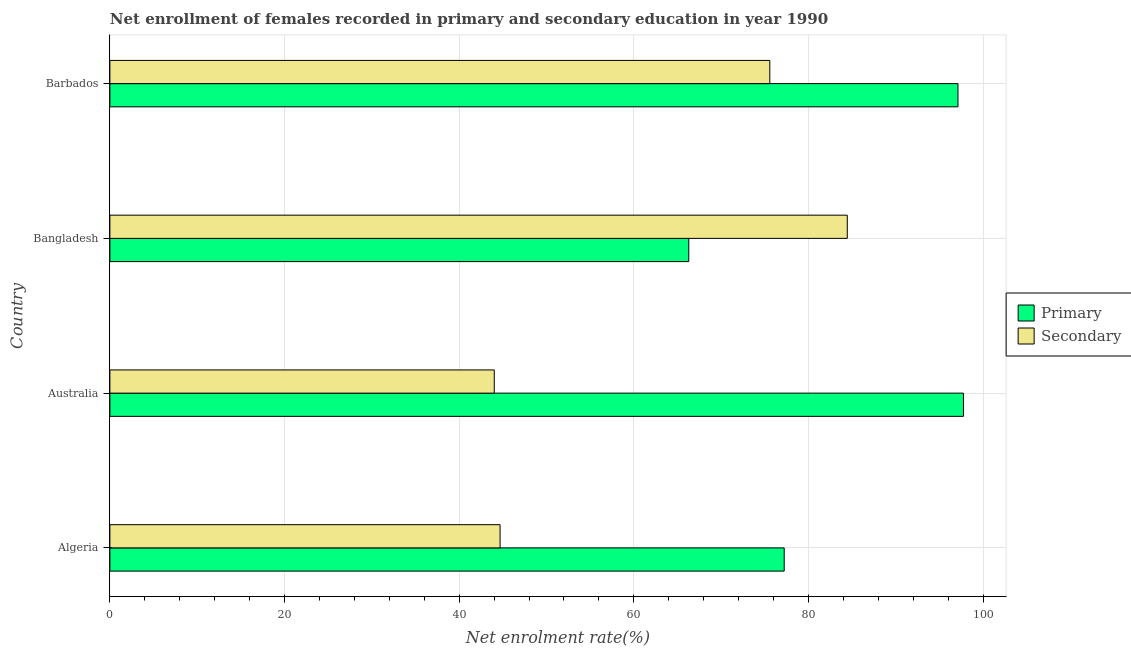How many different coloured bars are there?
Give a very brief answer. 2. How many groups of bars are there?
Your answer should be compact. 4. Are the number of bars per tick equal to the number of legend labels?
Keep it short and to the point. Yes. Are the number of bars on each tick of the Y-axis equal?
Provide a succinct answer. Yes. How many bars are there on the 4th tick from the top?
Your answer should be compact. 2. How many bars are there on the 3rd tick from the bottom?
Your answer should be very brief. 2. What is the label of the 2nd group of bars from the top?
Keep it short and to the point. Bangladesh. What is the enrollment rate in primary education in Algeria?
Provide a succinct answer. 77.23. Across all countries, what is the maximum enrollment rate in primary education?
Keep it short and to the point. 97.76. Across all countries, what is the minimum enrollment rate in primary education?
Offer a very short reply. 66.3. In which country was the enrollment rate in secondary education maximum?
Your response must be concise. Bangladesh. What is the total enrollment rate in primary education in the graph?
Your response must be concise. 338.42. What is the difference between the enrollment rate in secondary education in Australia and that in Bangladesh?
Make the answer very short. -40.43. What is the difference between the enrollment rate in primary education in Bangladesh and the enrollment rate in secondary education in Algeria?
Your response must be concise. 21.61. What is the average enrollment rate in secondary education per country?
Your answer should be very brief. 62.19. What is the difference between the enrollment rate in secondary education and enrollment rate in primary education in Barbados?
Your answer should be compact. -21.55. What is the ratio of the enrollment rate in primary education in Australia to that in Barbados?
Provide a succinct answer. 1.01. Is the enrollment rate in secondary education in Algeria less than that in Bangladesh?
Your answer should be very brief. Yes. What is the difference between the highest and the second highest enrollment rate in secondary education?
Offer a very short reply. 8.87. What is the difference between the highest and the lowest enrollment rate in primary education?
Offer a terse response. 31.46. Is the sum of the enrollment rate in primary education in Algeria and Bangladesh greater than the maximum enrollment rate in secondary education across all countries?
Make the answer very short. Yes. What does the 2nd bar from the top in Algeria represents?
Offer a terse response. Primary. What does the 2nd bar from the bottom in Bangladesh represents?
Ensure brevity in your answer.  Secondary. Are all the bars in the graph horizontal?
Give a very brief answer. Yes. Does the graph contain any zero values?
Give a very brief answer. No. Does the graph contain grids?
Provide a succinct answer. Yes. Where does the legend appear in the graph?
Your response must be concise. Center right. What is the title of the graph?
Your response must be concise. Net enrollment of females recorded in primary and secondary education in year 1990. What is the label or title of the X-axis?
Your answer should be very brief. Net enrolment rate(%). What is the Net enrolment rate(%) of Primary in Algeria?
Provide a short and direct response. 77.23. What is the Net enrolment rate(%) of Secondary in Algeria?
Ensure brevity in your answer.  44.69. What is the Net enrolment rate(%) of Primary in Australia?
Give a very brief answer. 97.76. What is the Net enrolment rate(%) in Secondary in Australia?
Ensure brevity in your answer.  44.02. What is the Net enrolment rate(%) of Primary in Bangladesh?
Keep it short and to the point. 66.3. What is the Net enrolment rate(%) in Secondary in Bangladesh?
Provide a short and direct response. 84.45. What is the Net enrolment rate(%) of Primary in Barbados?
Your answer should be compact. 97.13. What is the Net enrolment rate(%) in Secondary in Barbados?
Your answer should be very brief. 75.58. Across all countries, what is the maximum Net enrolment rate(%) in Primary?
Keep it short and to the point. 97.76. Across all countries, what is the maximum Net enrolment rate(%) of Secondary?
Your answer should be very brief. 84.45. Across all countries, what is the minimum Net enrolment rate(%) of Primary?
Make the answer very short. 66.3. Across all countries, what is the minimum Net enrolment rate(%) in Secondary?
Keep it short and to the point. 44.02. What is the total Net enrolment rate(%) of Primary in the graph?
Provide a succinct answer. 338.42. What is the total Net enrolment rate(%) in Secondary in the graph?
Keep it short and to the point. 248.74. What is the difference between the Net enrolment rate(%) of Primary in Algeria and that in Australia?
Make the answer very short. -20.53. What is the difference between the Net enrolment rate(%) in Secondary in Algeria and that in Australia?
Offer a terse response. 0.67. What is the difference between the Net enrolment rate(%) in Primary in Algeria and that in Bangladesh?
Your answer should be compact. 10.93. What is the difference between the Net enrolment rate(%) in Secondary in Algeria and that in Bangladesh?
Your answer should be compact. -39.76. What is the difference between the Net enrolment rate(%) in Primary in Algeria and that in Barbados?
Your answer should be very brief. -19.9. What is the difference between the Net enrolment rate(%) of Secondary in Algeria and that in Barbados?
Make the answer very short. -30.89. What is the difference between the Net enrolment rate(%) in Primary in Australia and that in Bangladesh?
Keep it short and to the point. 31.46. What is the difference between the Net enrolment rate(%) in Secondary in Australia and that in Bangladesh?
Offer a very short reply. -40.43. What is the difference between the Net enrolment rate(%) of Primary in Australia and that in Barbados?
Give a very brief answer. 0.63. What is the difference between the Net enrolment rate(%) in Secondary in Australia and that in Barbados?
Your answer should be very brief. -31.56. What is the difference between the Net enrolment rate(%) in Primary in Bangladesh and that in Barbados?
Keep it short and to the point. -30.83. What is the difference between the Net enrolment rate(%) of Secondary in Bangladesh and that in Barbados?
Ensure brevity in your answer.  8.87. What is the difference between the Net enrolment rate(%) in Primary in Algeria and the Net enrolment rate(%) in Secondary in Australia?
Keep it short and to the point. 33.21. What is the difference between the Net enrolment rate(%) in Primary in Algeria and the Net enrolment rate(%) in Secondary in Bangladesh?
Your answer should be compact. -7.22. What is the difference between the Net enrolment rate(%) in Primary in Algeria and the Net enrolment rate(%) in Secondary in Barbados?
Offer a very short reply. 1.65. What is the difference between the Net enrolment rate(%) of Primary in Australia and the Net enrolment rate(%) of Secondary in Bangladesh?
Make the answer very short. 13.31. What is the difference between the Net enrolment rate(%) of Primary in Australia and the Net enrolment rate(%) of Secondary in Barbados?
Keep it short and to the point. 22.18. What is the difference between the Net enrolment rate(%) of Primary in Bangladesh and the Net enrolment rate(%) of Secondary in Barbados?
Offer a very short reply. -9.28. What is the average Net enrolment rate(%) of Primary per country?
Your response must be concise. 84.6. What is the average Net enrolment rate(%) of Secondary per country?
Provide a short and direct response. 62.19. What is the difference between the Net enrolment rate(%) of Primary and Net enrolment rate(%) of Secondary in Algeria?
Give a very brief answer. 32.54. What is the difference between the Net enrolment rate(%) of Primary and Net enrolment rate(%) of Secondary in Australia?
Give a very brief answer. 53.74. What is the difference between the Net enrolment rate(%) of Primary and Net enrolment rate(%) of Secondary in Bangladesh?
Offer a terse response. -18.15. What is the difference between the Net enrolment rate(%) of Primary and Net enrolment rate(%) of Secondary in Barbados?
Keep it short and to the point. 21.55. What is the ratio of the Net enrolment rate(%) in Primary in Algeria to that in Australia?
Provide a short and direct response. 0.79. What is the ratio of the Net enrolment rate(%) in Secondary in Algeria to that in Australia?
Provide a succinct answer. 1.02. What is the ratio of the Net enrolment rate(%) in Primary in Algeria to that in Bangladesh?
Offer a terse response. 1.16. What is the ratio of the Net enrolment rate(%) in Secondary in Algeria to that in Bangladesh?
Provide a short and direct response. 0.53. What is the ratio of the Net enrolment rate(%) of Primary in Algeria to that in Barbados?
Your answer should be compact. 0.8. What is the ratio of the Net enrolment rate(%) in Secondary in Algeria to that in Barbados?
Offer a terse response. 0.59. What is the ratio of the Net enrolment rate(%) in Primary in Australia to that in Bangladesh?
Your answer should be very brief. 1.47. What is the ratio of the Net enrolment rate(%) in Secondary in Australia to that in Bangladesh?
Your response must be concise. 0.52. What is the ratio of the Net enrolment rate(%) of Primary in Australia to that in Barbados?
Your response must be concise. 1.01. What is the ratio of the Net enrolment rate(%) of Secondary in Australia to that in Barbados?
Your response must be concise. 0.58. What is the ratio of the Net enrolment rate(%) in Primary in Bangladesh to that in Barbados?
Your response must be concise. 0.68. What is the ratio of the Net enrolment rate(%) in Secondary in Bangladesh to that in Barbados?
Provide a short and direct response. 1.12. What is the difference between the highest and the second highest Net enrolment rate(%) of Primary?
Make the answer very short. 0.63. What is the difference between the highest and the second highest Net enrolment rate(%) in Secondary?
Offer a terse response. 8.87. What is the difference between the highest and the lowest Net enrolment rate(%) in Primary?
Ensure brevity in your answer.  31.46. What is the difference between the highest and the lowest Net enrolment rate(%) in Secondary?
Ensure brevity in your answer.  40.43. 